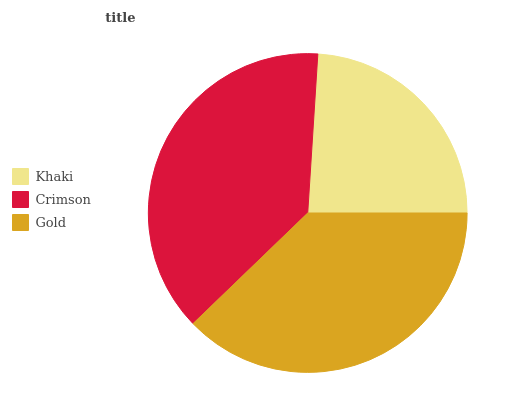Is Khaki the minimum?
Answer yes or no. Yes. Is Crimson the maximum?
Answer yes or no. Yes. Is Gold the minimum?
Answer yes or no. No. Is Gold the maximum?
Answer yes or no. No. Is Crimson greater than Gold?
Answer yes or no. Yes. Is Gold less than Crimson?
Answer yes or no. Yes. Is Gold greater than Crimson?
Answer yes or no. No. Is Crimson less than Gold?
Answer yes or no. No. Is Gold the high median?
Answer yes or no. Yes. Is Gold the low median?
Answer yes or no. Yes. Is Crimson the high median?
Answer yes or no. No. Is Crimson the low median?
Answer yes or no. No. 